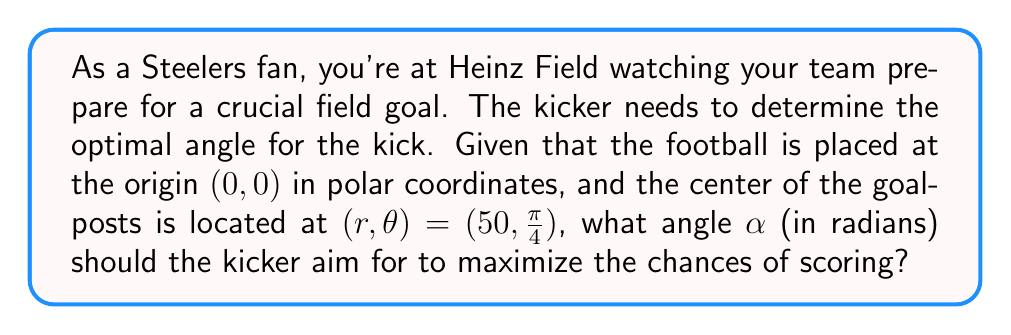Can you solve this math problem? To solve this problem, we need to follow these steps:

1) In polar coordinates, the point $(r,\theta) = (50, \frac{\pi}{4})$ represents the center of the goalposts. We need to find the angle $\alpha$ from the positive x-axis to this point.

2) In polar coordinates, $\theta$ represents the angle from the positive x-axis to the line connecting the origin to the point. Therefore, the angle we're looking for is already given as $\frac{\pi}{4}$.

3) To verify this visually, we can convert the polar coordinates to Cartesian coordinates:

   $x = r \cos(\theta) = 50 \cos(\frac{\pi}{4}) \approx 35.36$
   $y = r \sin(\theta) = 50 \sin(\frac{\pi}{4}) \approx 35.36$

4) We can visualize this with a diagram:

[asy]
import geometry;

unitsize(2mm);

pair O=(0,0);
pair G=(35.36,35.36);

draw(O--G,Arrow);
draw((-10,0)--(60,0),Arrow);
draw((0,-10)--(0,60),Arrow);

label("O", O, SW);
label("G", G, NE);
label("50", (17.68,17.68), NW);
label("$\alpha = \frac{\pi}{4}$", (10,10), SE);

draw(arc(O,10,0,45),Arrow);
[/asy]

5) The optimal angle for the kick is therefore $\alpha = \frac{\pi}{4}$ radians, which is equivalent to 45 degrees.
Answer: $\alpha = \frac{\pi}{4}$ radians 